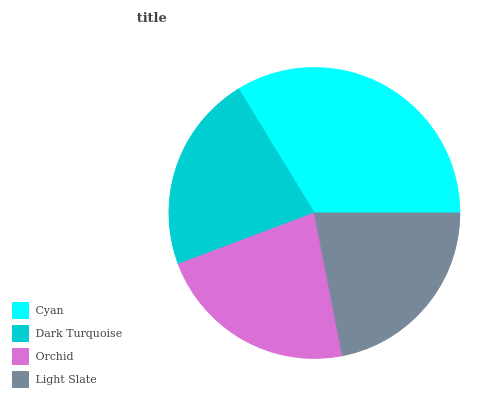Is Light Slate the minimum?
Answer yes or no. Yes. Is Cyan the maximum?
Answer yes or no. Yes. Is Dark Turquoise the minimum?
Answer yes or no. No. Is Dark Turquoise the maximum?
Answer yes or no. No. Is Cyan greater than Dark Turquoise?
Answer yes or no. Yes. Is Dark Turquoise less than Cyan?
Answer yes or no. Yes. Is Dark Turquoise greater than Cyan?
Answer yes or no. No. Is Cyan less than Dark Turquoise?
Answer yes or no. No. Is Orchid the high median?
Answer yes or no. Yes. Is Dark Turquoise the low median?
Answer yes or no. Yes. Is Light Slate the high median?
Answer yes or no. No. Is Cyan the low median?
Answer yes or no. No. 